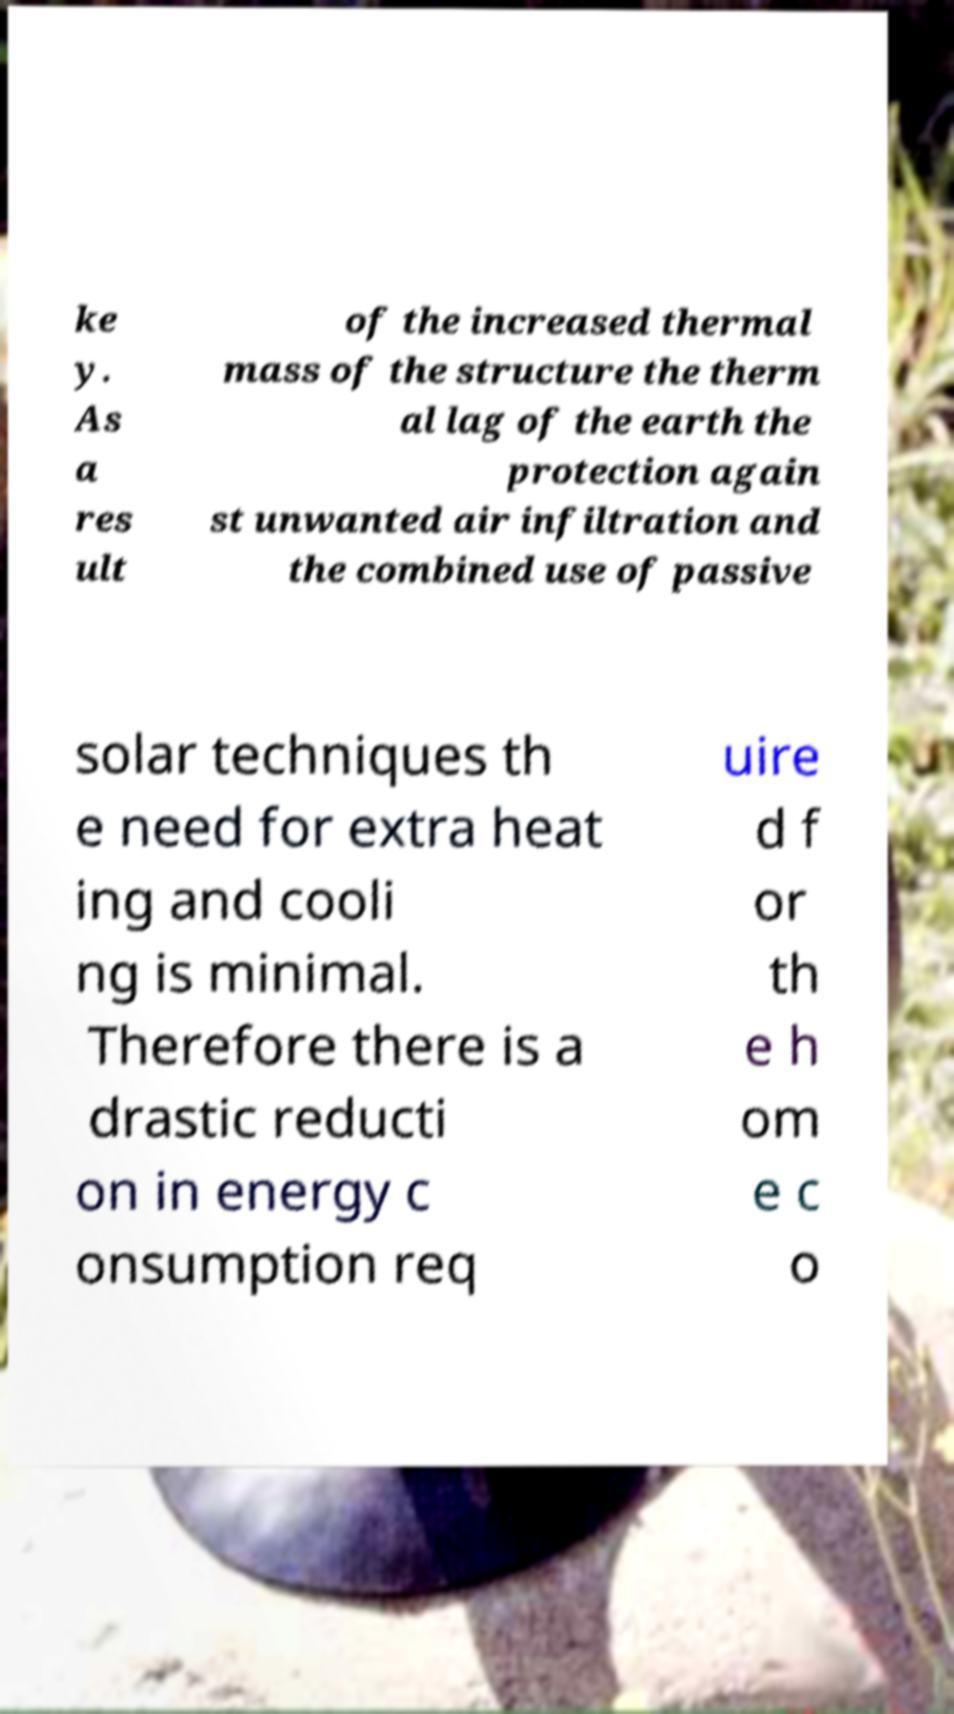Could you extract and type out the text from this image? ke y. As a res ult of the increased thermal mass of the structure the therm al lag of the earth the protection again st unwanted air infiltration and the combined use of passive solar techniques th e need for extra heat ing and cooli ng is minimal. Therefore there is a drastic reducti on in energy c onsumption req uire d f or th e h om e c o 